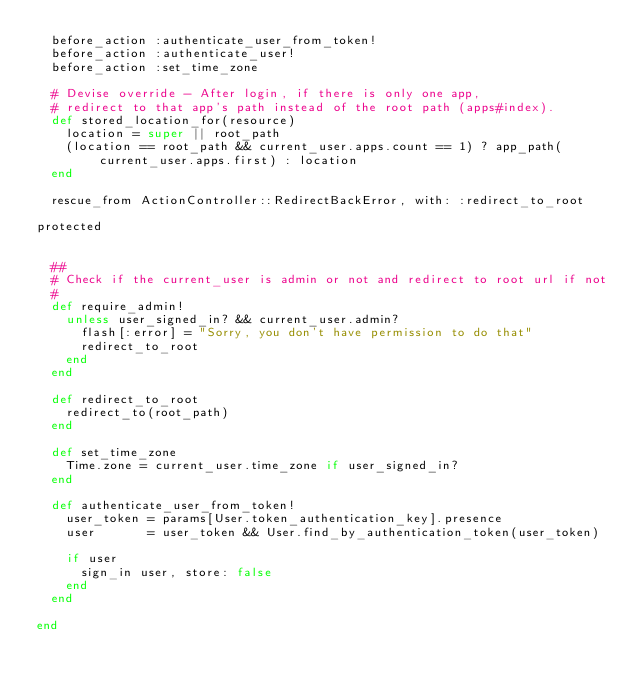Convert code to text. <code><loc_0><loc_0><loc_500><loc_500><_Ruby_>  before_action :authenticate_user_from_token!
  before_action :authenticate_user!
  before_action :set_time_zone

  # Devise override - After login, if there is only one app,
  # redirect to that app's path instead of the root path (apps#index).
  def stored_location_for(resource)
    location = super || root_path
    (location == root_path && current_user.apps.count == 1) ? app_path(current_user.apps.first) : location
  end

  rescue_from ActionController::RedirectBackError, with: :redirect_to_root

protected


  ##
  # Check if the current_user is admin or not and redirect to root url if not
  #
  def require_admin!
    unless user_signed_in? && current_user.admin?
      flash[:error] = "Sorry, you don't have permission to do that"
      redirect_to_root
    end
  end

  def redirect_to_root
    redirect_to(root_path)
  end

  def set_time_zone
    Time.zone = current_user.time_zone if user_signed_in?
  end

  def authenticate_user_from_token!
    user_token = params[User.token_authentication_key].presence
    user       = user_token && User.find_by_authentication_token(user_token)

    if user
      sign_in user, store: false
    end
  end

end
</code> 